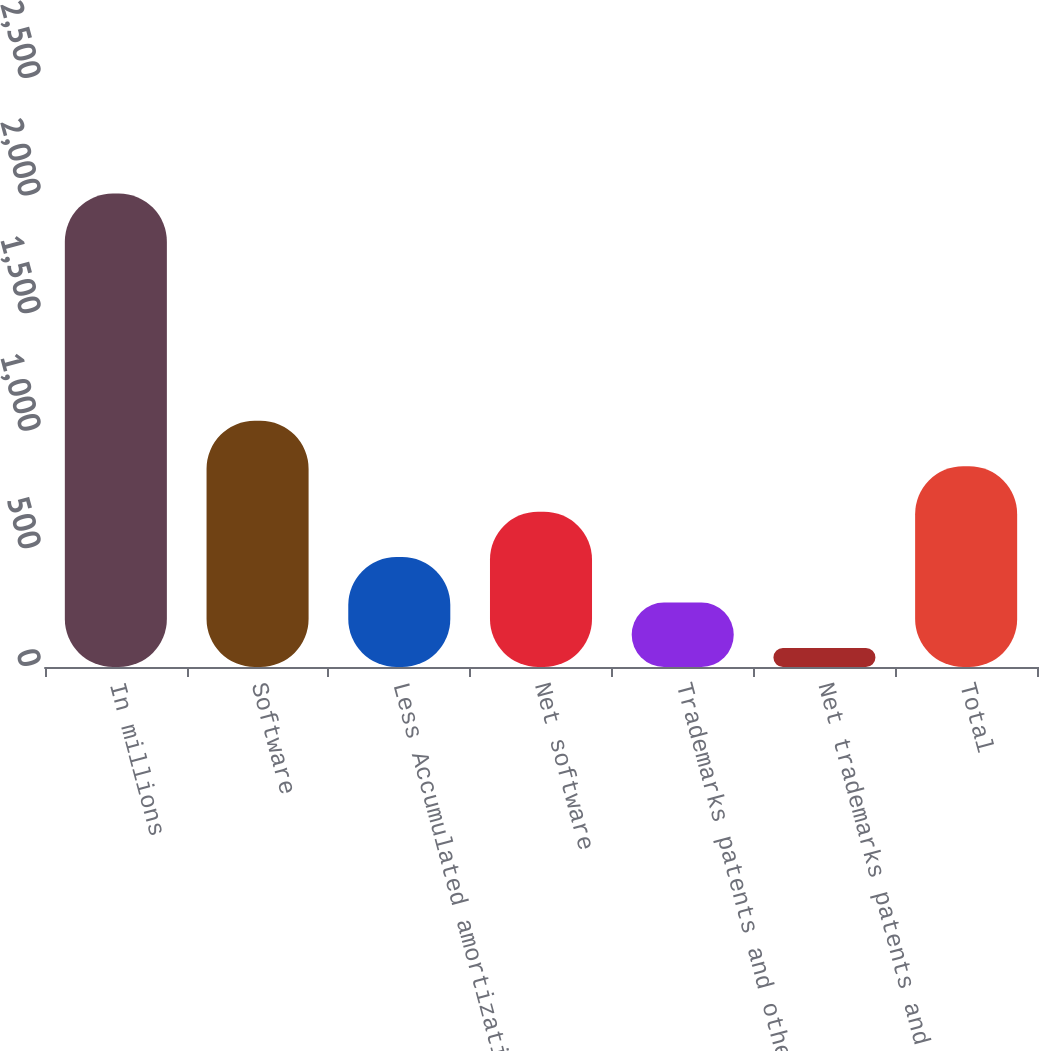<chart> <loc_0><loc_0><loc_500><loc_500><bar_chart><fcel>In millions<fcel>Software<fcel>Less Accumulated amortization<fcel>Net software<fcel>Trademarks patents and other<fcel>Net trademarks patents and<fcel>Total<nl><fcel>2013<fcel>1047<fcel>467.4<fcel>660.6<fcel>274.2<fcel>81<fcel>853.8<nl></chart> 